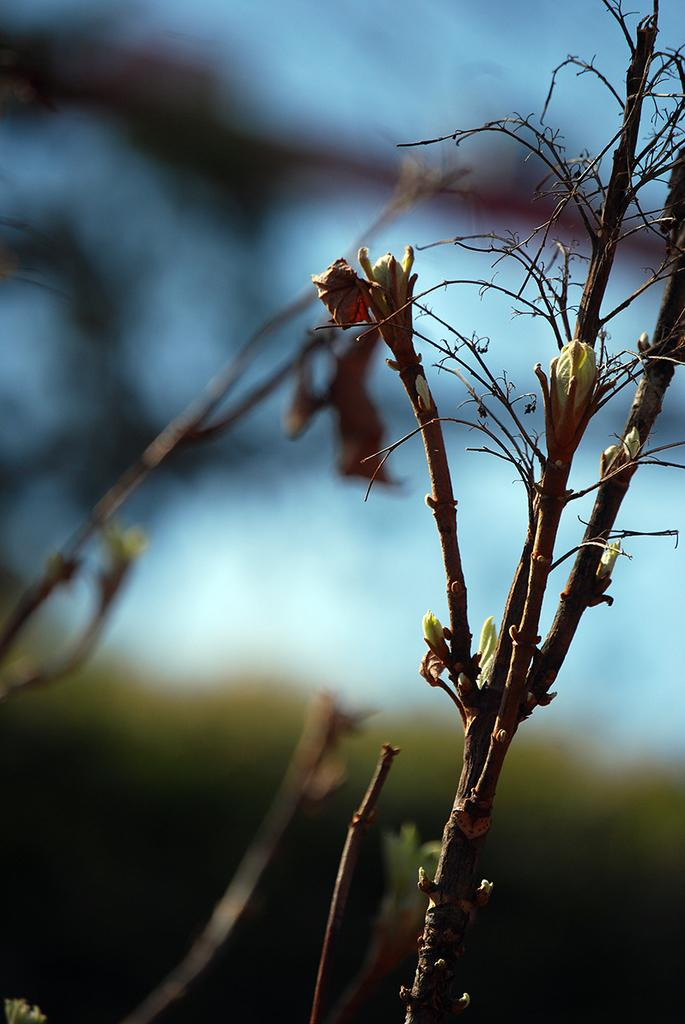What type of living organisms can be seen in the image? Plants can be seen in the image. Can you describe the background of the image? The background of the image is blurry. What type of dinner is being served in the image? There is no dinner present in the image; it only features plants and a blurry background. How many clocks can be seen in the image? There are no clocks visible in the image. 